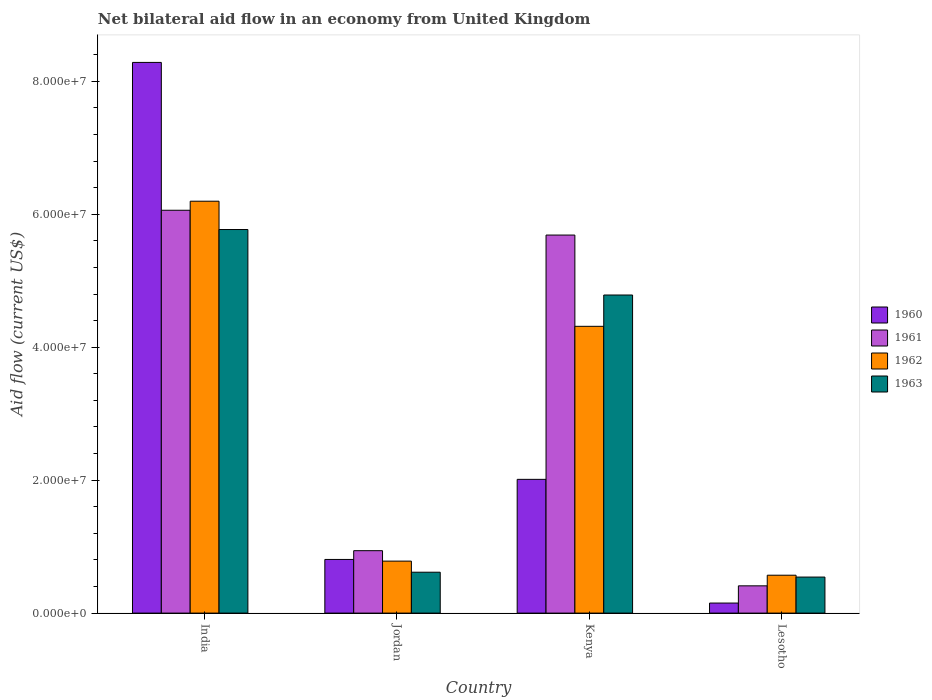How many different coloured bars are there?
Provide a succinct answer. 4. Are the number of bars on each tick of the X-axis equal?
Provide a succinct answer. Yes. How many bars are there on the 2nd tick from the right?
Your answer should be compact. 4. What is the label of the 4th group of bars from the left?
Offer a terse response. Lesotho. In how many cases, is the number of bars for a given country not equal to the number of legend labels?
Make the answer very short. 0. What is the net bilateral aid flow in 1961 in India?
Make the answer very short. 6.06e+07. Across all countries, what is the maximum net bilateral aid flow in 1962?
Provide a short and direct response. 6.20e+07. Across all countries, what is the minimum net bilateral aid flow in 1962?
Offer a terse response. 5.70e+06. In which country was the net bilateral aid flow in 1960 maximum?
Your response must be concise. India. In which country was the net bilateral aid flow in 1963 minimum?
Your answer should be compact. Lesotho. What is the total net bilateral aid flow in 1962 in the graph?
Make the answer very short. 1.19e+08. What is the difference between the net bilateral aid flow in 1962 in India and that in Kenya?
Keep it short and to the point. 1.88e+07. What is the difference between the net bilateral aid flow in 1960 in Kenya and the net bilateral aid flow in 1962 in Jordan?
Provide a short and direct response. 1.23e+07. What is the average net bilateral aid flow in 1963 per country?
Give a very brief answer. 2.93e+07. What is the difference between the net bilateral aid flow of/in 1960 and net bilateral aid flow of/in 1962 in India?
Ensure brevity in your answer.  2.09e+07. What is the ratio of the net bilateral aid flow in 1962 in Jordan to that in Kenya?
Give a very brief answer. 0.18. Is the difference between the net bilateral aid flow in 1960 in India and Lesotho greater than the difference between the net bilateral aid flow in 1962 in India and Lesotho?
Ensure brevity in your answer.  Yes. What is the difference between the highest and the second highest net bilateral aid flow in 1961?
Give a very brief answer. 3.73e+06. What is the difference between the highest and the lowest net bilateral aid flow in 1963?
Your answer should be very brief. 5.23e+07. Is the sum of the net bilateral aid flow in 1960 in India and Kenya greater than the maximum net bilateral aid flow in 1961 across all countries?
Your response must be concise. Yes. What does the 4th bar from the left in India represents?
Make the answer very short. 1963. What does the 2nd bar from the right in Lesotho represents?
Your answer should be very brief. 1962. How many bars are there?
Your answer should be compact. 16. What is the difference between two consecutive major ticks on the Y-axis?
Ensure brevity in your answer.  2.00e+07. Does the graph contain grids?
Provide a short and direct response. No. Where does the legend appear in the graph?
Ensure brevity in your answer.  Center right. How many legend labels are there?
Your answer should be compact. 4. What is the title of the graph?
Your answer should be compact. Net bilateral aid flow in an economy from United Kingdom. Does "1978" appear as one of the legend labels in the graph?
Give a very brief answer. No. What is the label or title of the X-axis?
Provide a succinct answer. Country. What is the Aid flow (current US$) in 1960 in India?
Offer a terse response. 8.28e+07. What is the Aid flow (current US$) in 1961 in India?
Make the answer very short. 6.06e+07. What is the Aid flow (current US$) of 1962 in India?
Ensure brevity in your answer.  6.20e+07. What is the Aid flow (current US$) in 1963 in India?
Your answer should be compact. 5.77e+07. What is the Aid flow (current US$) of 1960 in Jordan?
Give a very brief answer. 8.07e+06. What is the Aid flow (current US$) of 1961 in Jordan?
Offer a terse response. 9.39e+06. What is the Aid flow (current US$) of 1962 in Jordan?
Make the answer very short. 7.82e+06. What is the Aid flow (current US$) in 1963 in Jordan?
Your answer should be compact. 6.15e+06. What is the Aid flow (current US$) in 1960 in Kenya?
Offer a terse response. 2.01e+07. What is the Aid flow (current US$) in 1961 in Kenya?
Your answer should be compact. 5.69e+07. What is the Aid flow (current US$) of 1962 in Kenya?
Ensure brevity in your answer.  4.31e+07. What is the Aid flow (current US$) in 1963 in Kenya?
Ensure brevity in your answer.  4.78e+07. What is the Aid flow (current US$) in 1960 in Lesotho?
Offer a very short reply. 1.51e+06. What is the Aid flow (current US$) of 1961 in Lesotho?
Your response must be concise. 4.10e+06. What is the Aid flow (current US$) of 1962 in Lesotho?
Offer a terse response. 5.70e+06. What is the Aid flow (current US$) in 1963 in Lesotho?
Provide a short and direct response. 5.42e+06. Across all countries, what is the maximum Aid flow (current US$) of 1960?
Ensure brevity in your answer.  8.28e+07. Across all countries, what is the maximum Aid flow (current US$) of 1961?
Keep it short and to the point. 6.06e+07. Across all countries, what is the maximum Aid flow (current US$) in 1962?
Your response must be concise. 6.20e+07. Across all countries, what is the maximum Aid flow (current US$) in 1963?
Provide a succinct answer. 5.77e+07. Across all countries, what is the minimum Aid flow (current US$) of 1960?
Make the answer very short. 1.51e+06. Across all countries, what is the minimum Aid flow (current US$) of 1961?
Offer a terse response. 4.10e+06. Across all countries, what is the minimum Aid flow (current US$) of 1962?
Your response must be concise. 5.70e+06. Across all countries, what is the minimum Aid flow (current US$) in 1963?
Make the answer very short. 5.42e+06. What is the total Aid flow (current US$) in 1960 in the graph?
Keep it short and to the point. 1.13e+08. What is the total Aid flow (current US$) in 1961 in the graph?
Ensure brevity in your answer.  1.31e+08. What is the total Aid flow (current US$) in 1962 in the graph?
Make the answer very short. 1.19e+08. What is the total Aid flow (current US$) in 1963 in the graph?
Offer a terse response. 1.17e+08. What is the difference between the Aid flow (current US$) in 1960 in India and that in Jordan?
Keep it short and to the point. 7.48e+07. What is the difference between the Aid flow (current US$) in 1961 in India and that in Jordan?
Your answer should be very brief. 5.12e+07. What is the difference between the Aid flow (current US$) of 1962 in India and that in Jordan?
Give a very brief answer. 5.41e+07. What is the difference between the Aid flow (current US$) in 1963 in India and that in Jordan?
Provide a succinct answer. 5.16e+07. What is the difference between the Aid flow (current US$) in 1960 in India and that in Kenya?
Offer a terse response. 6.27e+07. What is the difference between the Aid flow (current US$) of 1961 in India and that in Kenya?
Offer a very short reply. 3.73e+06. What is the difference between the Aid flow (current US$) of 1962 in India and that in Kenya?
Provide a short and direct response. 1.88e+07. What is the difference between the Aid flow (current US$) in 1963 in India and that in Kenya?
Offer a terse response. 9.85e+06. What is the difference between the Aid flow (current US$) of 1960 in India and that in Lesotho?
Your answer should be compact. 8.13e+07. What is the difference between the Aid flow (current US$) in 1961 in India and that in Lesotho?
Keep it short and to the point. 5.65e+07. What is the difference between the Aid flow (current US$) in 1962 in India and that in Lesotho?
Your answer should be very brief. 5.63e+07. What is the difference between the Aid flow (current US$) in 1963 in India and that in Lesotho?
Offer a terse response. 5.23e+07. What is the difference between the Aid flow (current US$) in 1960 in Jordan and that in Kenya?
Keep it short and to the point. -1.20e+07. What is the difference between the Aid flow (current US$) in 1961 in Jordan and that in Kenya?
Give a very brief answer. -4.75e+07. What is the difference between the Aid flow (current US$) in 1962 in Jordan and that in Kenya?
Ensure brevity in your answer.  -3.53e+07. What is the difference between the Aid flow (current US$) in 1963 in Jordan and that in Kenya?
Your answer should be compact. -4.17e+07. What is the difference between the Aid flow (current US$) in 1960 in Jordan and that in Lesotho?
Your answer should be very brief. 6.56e+06. What is the difference between the Aid flow (current US$) in 1961 in Jordan and that in Lesotho?
Give a very brief answer. 5.29e+06. What is the difference between the Aid flow (current US$) in 1962 in Jordan and that in Lesotho?
Provide a succinct answer. 2.12e+06. What is the difference between the Aid flow (current US$) in 1963 in Jordan and that in Lesotho?
Provide a short and direct response. 7.30e+05. What is the difference between the Aid flow (current US$) of 1960 in Kenya and that in Lesotho?
Provide a succinct answer. 1.86e+07. What is the difference between the Aid flow (current US$) in 1961 in Kenya and that in Lesotho?
Ensure brevity in your answer.  5.28e+07. What is the difference between the Aid flow (current US$) of 1962 in Kenya and that in Lesotho?
Keep it short and to the point. 3.74e+07. What is the difference between the Aid flow (current US$) in 1963 in Kenya and that in Lesotho?
Provide a short and direct response. 4.24e+07. What is the difference between the Aid flow (current US$) in 1960 in India and the Aid flow (current US$) in 1961 in Jordan?
Make the answer very short. 7.34e+07. What is the difference between the Aid flow (current US$) of 1960 in India and the Aid flow (current US$) of 1962 in Jordan?
Give a very brief answer. 7.50e+07. What is the difference between the Aid flow (current US$) of 1960 in India and the Aid flow (current US$) of 1963 in Jordan?
Provide a succinct answer. 7.67e+07. What is the difference between the Aid flow (current US$) of 1961 in India and the Aid flow (current US$) of 1962 in Jordan?
Your answer should be very brief. 5.28e+07. What is the difference between the Aid flow (current US$) in 1961 in India and the Aid flow (current US$) in 1963 in Jordan?
Your response must be concise. 5.44e+07. What is the difference between the Aid flow (current US$) of 1962 in India and the Aid flow (current US$) of 1963 in Jordan?
Offer a terse response. 5.58e+07. What is the difference between the Aid flow (current US$) of 1960 in India and the Aid flow (current US$) of 1961 in Kenya?
Offer a very short reply. 2.60e+07. What is the difference between the Aid flow (current US$) of 1960 in India and the Aid flow (current US$) of 1962 in Kenya?
Provide a short and direct response. 3.97e+07. What is the difference between the Aid flow (current US$) of 1960 in India and the Aid flow (current US$) of 1963 in Kenya?
Keep it short and to the point. 3.50e+07. What is the difference between the Aid flow (current US$) of 1961 in India and the Aid flow (current US$) of 1962 in Kenya?
Ensure brevity in your answer.  1.75e+07. What is the difference between the Aid flow (current US$) of 1961 in India and the Aid flow (current US$) of 1963 in Kenya?
Keep it short and to the point. 1.28e+07. What is the difference between the Aid flow (current US$) of 1962 in India and the Aid flow (current US$) of 1963 in Kenya?
Make the answer very short. 1.41e+07. What is the difference between the Aid flow (current US$) in 1960 in India and the Aid flow (current US$) in 1961 in Lesotho?
Offer a terse response. 7.87e+07. What is the difference between the Aid flow (current US$) in 1960 in India and the Aid flow (current US$) in 1962 in Lesotho?
Your answer should be compact. 7.71e+07. What is the difference between the Aid flow (current US$) of 1960 in India and the Aid flow (current US$) of 1963 in Lesotho?
Provide a short and direct response. 7.74e+07. What is the difference between the Aid flow (current US$) in 1961 in India and the Aid flow (current US$) in 1962 in Lesotho?
Offer a very short reply. 5.49e+07. What is the difference between the Aid flow (current US$) in 1961 in India and the Aid flow (current US$) in 1963 in Lesotho?
Your answer should be very brief. 5.52e+07. What is the difference between the Aid flow (current US$) in 1962 in India and the Aid flow (current US$) in 1963 in Lesotho?
Offer a very short reply. 5.65e+07. What is the difference between the Aid flow (current US$) of 1960 in Jordan and the Aid flow (current US$) of 1961 in Kenya?
Make the answer very short. -4.88e+07. What is the difference between the Aid flow (current US$) in 1960 in Jordan and the Aid flow (current US$) in 1962 in Kenya?
Provide a succinct answer. -3.51e+07. What is the difference between the Aid flow (current US$) in 1960 in Jordan and the Aid flow (current US$) in 1963 in Kenya?
Your answer should be very brief. -3.98e+07. What is the difference between the Aid flow (current US$) in 1961 in Jordan and the Aid flow (current US$) in 1962 in Kenya?
Your answer should be very brief. -3.38e+07. What is the difference between the Aid flow (current US$) in 1961 in Jordan and the Aid flow (current US$) in 1963 in Kenya?
Offer a very short reply. -3.85e+07. What is the difference between the Aid flow (current US$) in 1962 in Jordan and the Aid flow (current US$) in 1963 in Kenya?
Make the answer very short. -4.00e+07. What is the difference between the Aid flow (current US$) in 1960 in Jordan and the Aid flow (current US$) in 1961 in Lesotho?
Keep it short and to the point. 3.97e+06. What is the difference between the Aid flow (current US$) in 1960 in Jordan and the Aid flow (current US$) in 1962 in Lesotho?
Offer a very short reply. 2.37e+06. What is the difference between the Aid flow (current US$) of 1960 in Jordan and the Aid flow (current US$) of 1963 in Lesotho?
Make the answer very short. 2.65e+06. What is the difference between the Aid flow (current US$) in 1961 in Jordan and the Aid flow (current US$) in 1962 in Lesotho?
Your answer should be very brief. 3.69e+06. What is the difference between the Aid flow (current US$) in 1961 in Jordan and the Aid flow (current US$) in 1963 in Lesotho?
Provide a succinct answer. 3.97e+06. What is the difference between the Aid flow (current US$) in 1962 in Jordan and the Aid flow (current US$) in 1963 in Lesotho?
Your answer should be compact. 2.40e+06. What is the difference between the Aid flow (current US$) of 1960 in Kenya and the Aid flow (current US$) of 1961 in Lesotho?
Provide a short and direct response. 1.60e+07. What is the difference between the Aid flow (current US$) in 1960 in Kenya and the Aid flow (current US$) in 1962 in Lesotho?
Keep it short and to the point. 1.44e+07. What is the difference between the Aid flow (current US$) in 1960 in Kenya and the Aid flow (current US$) in 1963 in Lesotho?
Ensure brevity in your answer.  1.47e+07. What is the difference between the Aid flow (current US$) in 1961 in Kenya and the Aid flow (current US$) in 1962 in Lesotho?
Give a very brief answer. 5.12e+07. What is the difference between the Aid flow (current US$) in 1961 in Kenya and the Aid flow (current US$) in 1963 in Lesotho?
Provide a succinct answer. 5.14e+07. What is the difference between the Aid flow (current US$) in 1962 in Kenya and the Aid flow (current US$) in 1963 in Lesotho?
Keep it short and to the point. 3.77e+07. What is the average Aid flow (current US$) in 1960 per country?
Your answer should be very brief. 2.81e+07. What is the average Aid flow (current US$) in 1961 per country?
Give a very brief answer. 3.27e+07. What is the average Aid flow (current US$) of 1962 per country?
Your answer should be compact. 2.97e+07. What is the average Aid flow (current US$) in 1963 per country?
Give a very brief answer. 2.93e+07. What is the difference between the Aid flow (current US$) in 1960 and Aid flow (current US$) in 1961 in India?
Your answer should be compact. 2.22e+07. What is the difference between the Aid flow (current US$) of 1960 and Aid flow (current US$) of 1962 in India?
Your answer should be compact. 2.09e+07. What is the difference between the Aid flow (current US$) in 1960 and Aid flow (current US$) in 1963 in India?
Your answer should be very brief. 2.51e+07. What is the difference between the Aid flow (current US$) in 1961 and Aid flow (current US$) in 1962 in India?
Offer a very short reply. -1.36e+06. What is the difference between the Aid flow (current US$) of 1961 and Aid flow (current US$) of 1963 in India?
Keep it short and to the point. 2.90e+06. What is the difference between the Aid flow (current US$) of 1962 and Aid flow (current US$) of 1963 in India?
Provide a short and direct response. 4.26e+06. What is the difference between the Aid flow (current US$) in 1960 and Aid flow (current US$) in 1961 in Jordan?
Your answer should be compact. -1.32e+06. What is the difference between the Aid flow (current US$) of 1960 and Aid flow (current US$) of 1962 in Jordan?
Your answer should be very brief. 2.50e+05. What is the difference between the Aid flow (current US$) of 1960 and Aid flow (current US$) of 1963 in Jordan?
Give a very brief answer. 1.92e+06. What is the difference between the Aid flow (current US$) of 1961 and Aid flow (current US$) of 1962 in Jordan?
Give a very brief answer. 1.57e+06. What is the difference between the Aid flow (current US$) in 1961 and Aid flow (current US$) in 1963 in Jordan?
Your answer should be compact. 3.24e+06. What is the difference between the Aid flow (current US$) in 1962 and Aid flow (current US$) in 1963 in Jordan?
Give a very brief answer. 1.67e+06. What is the difference between the Aid flow (current US$) of 1960 and Aid flow (current US$) of 1961 in Kenya?
Offer a very short reply. -3.68e+07. What is the difference between the Aid flow (current US$) of 1960 and Aid flow (current US$) of 1962 in Kenya?
Your answer should be very brief. -2.30e+07. What is the difference between the Aid flow (current US$) of 1960 and Aid flow (current US$) of 1963 in Kenya?
Keep it short and to the point. -2.77e+07. What is the difference between the Aid flow (current US$) of 1961 and Aid flow (current US$) of 1962 in Kenya?
Your answer should be compact. 1.37e+07. What is the difference between the Aid flow (current US$) of 1961 and Aid flow (current US$) of 1963 in Kenya?
Keep it short and to the point. 9.02e+06. What is the difference between the Aid flow (current US$) in 1962 and Aid flow (current US$) in 1963 in Kenya?
Offer a very short reply. -4.71e+06. What is the difference between the Aid flow (current US$) of 1960 and Aid flow (current US$) of 1961 in Lesotho?
Ensure brevity in your answer.  -2.59e+06. What is the difference between the Aid flow (current US$) in 1960 and Aid flow (current US$) in 1962 in Lesotho?
Your response must be concise. -4.19e+06. What is the difference between the Aid flow (current US$) of 1960 and Aid flow (current US$) of 1963 in Lesotho?
Ensure brevity in your answer.  -3.91e+06. What is the difference between the Aid flow (current US$) in 1961 and Aid flow (current US$) in 1962 in Lesotho?
Offer a very short reply. -1.60e+06. What is the difference between the Aid flow (current US$) in 1961 and Aid flow (current US$) in 1963 in Lesotho?
Keep it short and to the point. -1.32e+06. What is the difference between the Aid flow (current US$) in 1962 and Aid flow (current US$) in 1963 in Lesotho?
Make the answer very short. 2.80e+05. What is the ratio of the Aid flow (current US$) in 1960 in India to that in Jordan?
Your answer should be very brief. 10.27. What is the ratio of the Aid flow (current US$) in 1961 in India to that in Jordan?
Give a very brief answer. 6.45. What is the ratio of the Aid flow (current US$) of 1962 in India to that in Jordan?
Offer a terse response. 7.92. What is the ratio of the Aid flow (current US$) of 1963 in India to that in Jordan?
Provide a short and direct response. 9.38. What is the ratio of the Aid flow (current US$) in 1960 in India to that in Kenya?
Your response must be concise. 4.12. What is the ratio of the Aid flow (current US$) in 1961 in India to that in Kenya?
Make the answer very short. 1.07. What is the ratio of the Aid flow (current US$) in 1962 in India to that in Kenya?
Ensure brevity in your answer.  1.44. What is the ratio of the Aid flow (current US$) of 1963 in India to that in Kenya?
Keep it short and to the point. 1.21. What is the ratio of the Aid flow (current US$) of 1960 in India to that in Lesotho?
Your response must be concise. 54.86. What is the ratio of the Aid flow (current US$) in 1961 in India to that in Lesotho?
Give a very brief answer. 14.78. What is the ratio of the Aid flow (current US$) of 1962 in India to that in Lesotho?
Make the answer very short. 10.87. What is the ratio of the Aid flow (current US$) in 1963 in India to that in Lesotho?
Provide a short and direct response. 10.65. What is the ratio of the Aid flow (current US$) of 1960 in Jordan to that in Kenya?
Offer a very short reply. 0.4. What is the ratio of the Aid flow (current US$) of 1961 in Jordan to that in Kenya?
Your answer should be very brief. 0.17. What is the ratio of the Aid flow (current US$) in 1962 in Jordan to that in Kenya?
Your answer should be compact. 0.18. What is the ratio of the Aid flow (current US$) in 1963 in Jordan to that in Kenya?
Your answer should be compact. 0.13. What is the ratio of the Aid flow (current US$) of 1960 in Jordan to that in Lesotho?
Ensure brevity in your answer.  5.34. What is the ratio of the Aid flow (current US$) of 1961 in Jordan to that in Lesotho?
Offer a terse response. 2.29. What is the ratio of the Aid flow (current US$) in 1962 in Jordan to that in Lesotho?
Ensure brevity in your answer.  1.37. What is the ratio of the Aid flow (current US$) in 1963 in Jordan to that in Lesotho?
Offer a very short reply. 1.13. What is the ratio of the Aid flow (current US$) in 1960 in Kenya to that in Lesotho?
Your answer should be compact. 13.32. What is the ratio of the Aid flow (current US$) of 1961 in Kenya to that in Lesotho?
Your answer should be very brief. 13.87. What is the ratio of the Aid flow (current US$) of 1962 in Kenya to that in Lesotho?
Offer a very short reply. 7.57. What is the ratio of the Aid flow (current US$) in 1963 in Kenya to that in Lesotho?
Keep it short and to the point. 8.83. What is the difference between the highest and the second highest Aid flow (current US$) in 1960?
Provide a short and direct response. 6.27e+07. What is the difference between the highest and the second highest Aid flow (current US$) in 1961?
Provide a short and direct response. 3.73e+06. What is the difference between the highest and the second highest Aid flow (current US$) in 1962?
Ensure brevity in your answer.  1.88e+07. What is the difference between the highest and the second highest Aid flow (current US$) in 1963?
Ensure brevity in your answer.  9.85e+06. What is the difference between the highest and the lowest Aid flow (current US$) in 1960?
Provide a succinct answer. 8.13e+07. What is the difference between the highest and the lowest Aid flow (current US$) of 1961?
Make the answer very short. 5.65e+07. What is the difference between the highest and the lowest Aid flow (current US$) of 1962?
Provide a succinct answer. 5.63e+07. What is the difference between the highest and the lowest Aid flow (current US$) of 1963?
Offer a very short reply. 5.23e+07. 